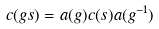<formula> <loc_0><loc_0><loc_500><loc_500>c ( g s ) = a ( g ) c ( s ) a ( g ^ { - 1 } )</formula> 